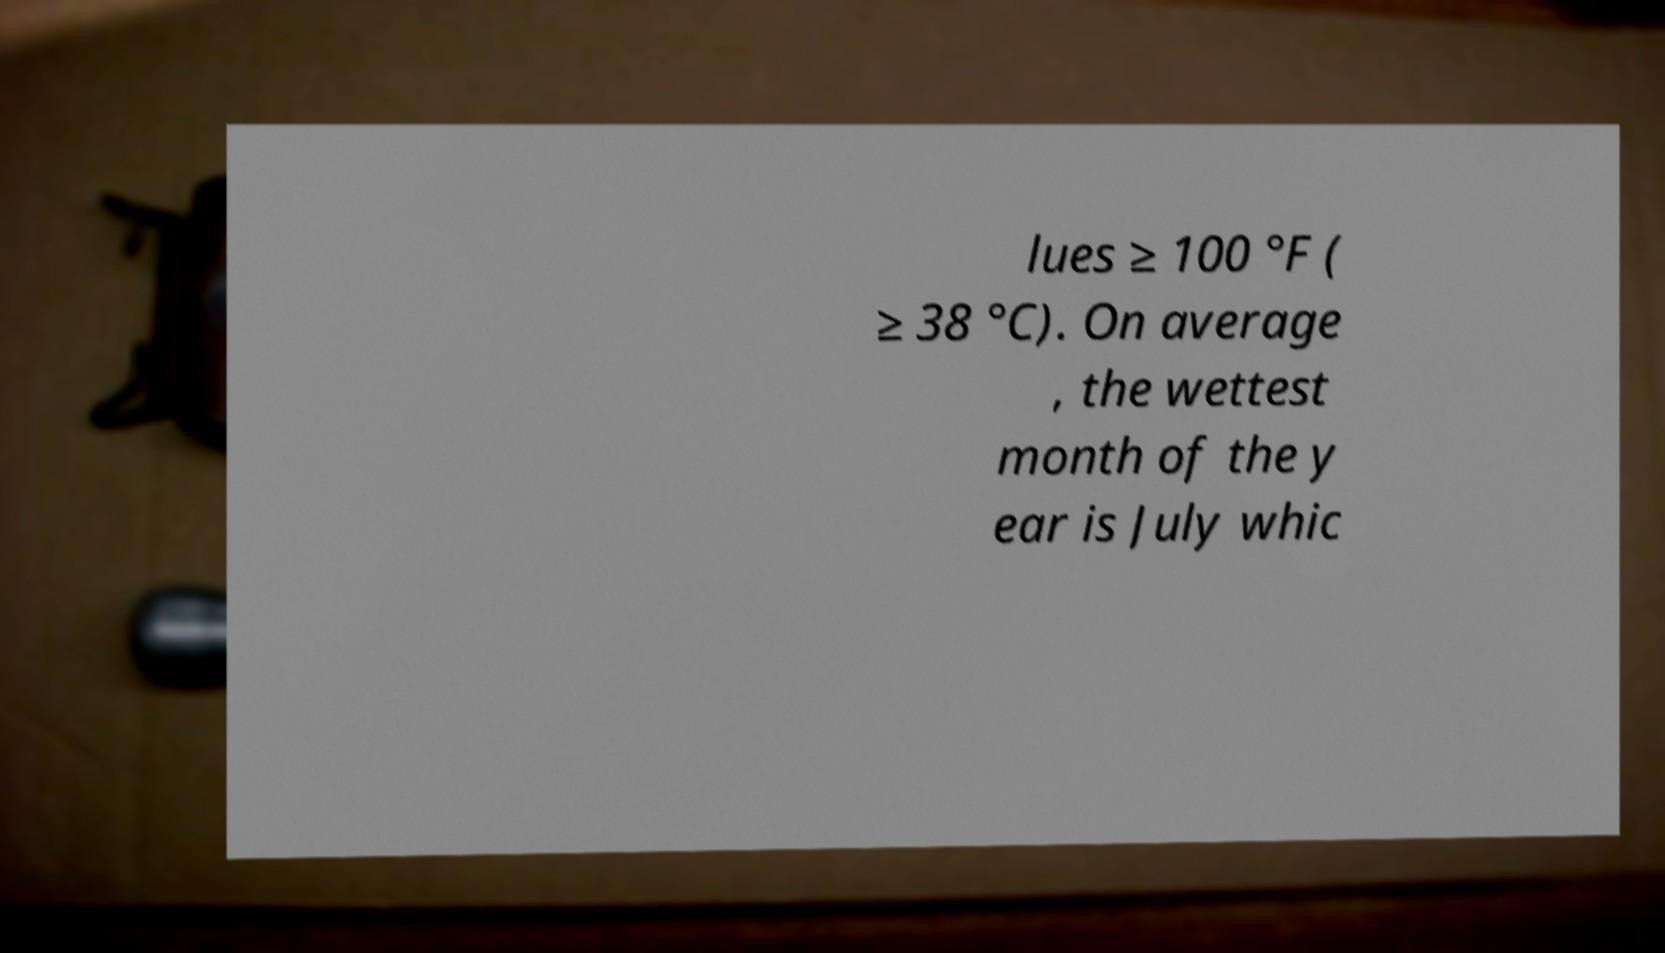Could you assist in decoding the text presented in this image and type it out clearly? lues ≥ 100 °F ( ≥ 38 °C). On average , the wettest month of the y ear is July whic 